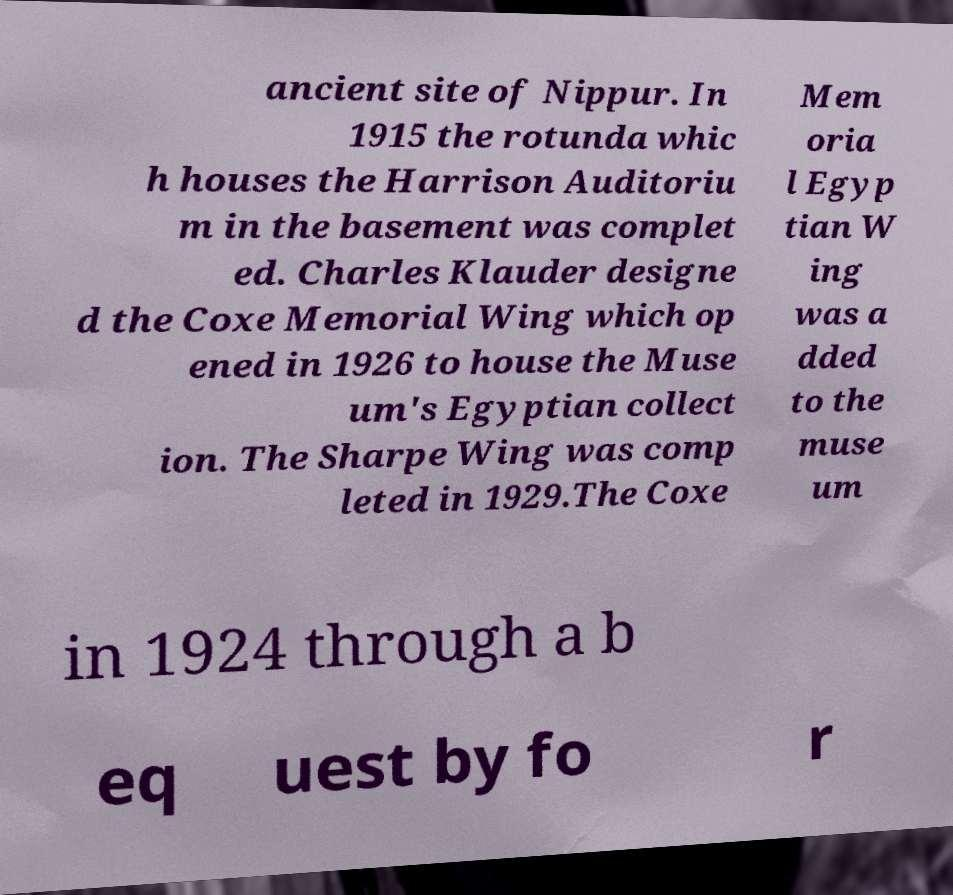Can you accurately transcribe the text from the provided image for me? ancient site of Nippur. In 1915 the rotunda whic h houses the Harrison Auditoriu m in the basement was complet ed. Charles Klauder designe d the Coxe Memorial Wing which op ened in 1926 to house the Muse um's Egyptian collect ion. The Sharpe Wing was comp leted in 1929.The Coxe Mem oria l Egyp tian W ing was a dded to the muse um in 1924 through a b eq uest by fo r 